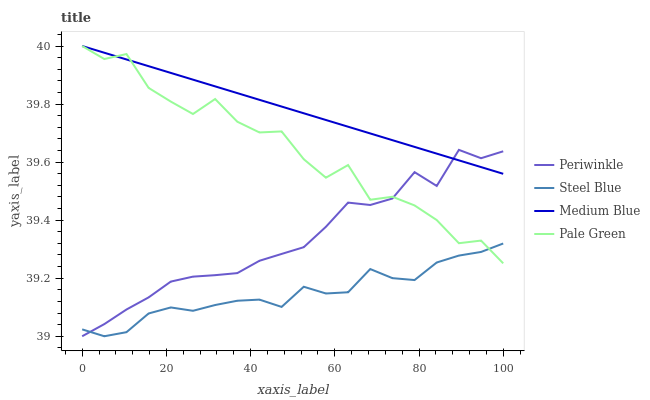Does Steel Blue have the minimum area under the curve?
Answer yes or no. Yes. Does Medium Blue have the maximum area under the curve?
Answer yes or no. Yes. Does Pale Green have the minimum area under the curve?
Answer yes or no. No. Does Pale Green have the maximum area under the curve?
Answer yes or no. No. Is Medium Blue the smoothest?
Answer yes or no. Yes. Is Pale Green the roughest?
Answer yes or no. Yes. Is Periwinkle the smoothest?
Answer yes or no. No. Is Periwinkle the roughest?
Answer yes or no. No. Does Periwinkle have the lowest value?
Answer yes or no. Yes. Does Pale Green have the lowest value?
Answer yes or no. No. Does Pale Green have the highest value?
Answer yes or no. Yes. Does Periwinkle have the highest value?
Answer yes or no. No. Is Steel Blue less than Medium Blue?
Answer yes or no. Yes. Is Medium Blue greater than Steel Blue?
Answer yes or no. Yes. Does Medium Blue intersect Pale Green?
Answer yes or no. Yes. Is Medium Blue less than Pale Green?
Answer yes or no. No. Is Medium Blue greater than Pale Green?
Answer yes or no. No. Does Steel Blue intersect Medium Blue?
Answer yes or no. No. 